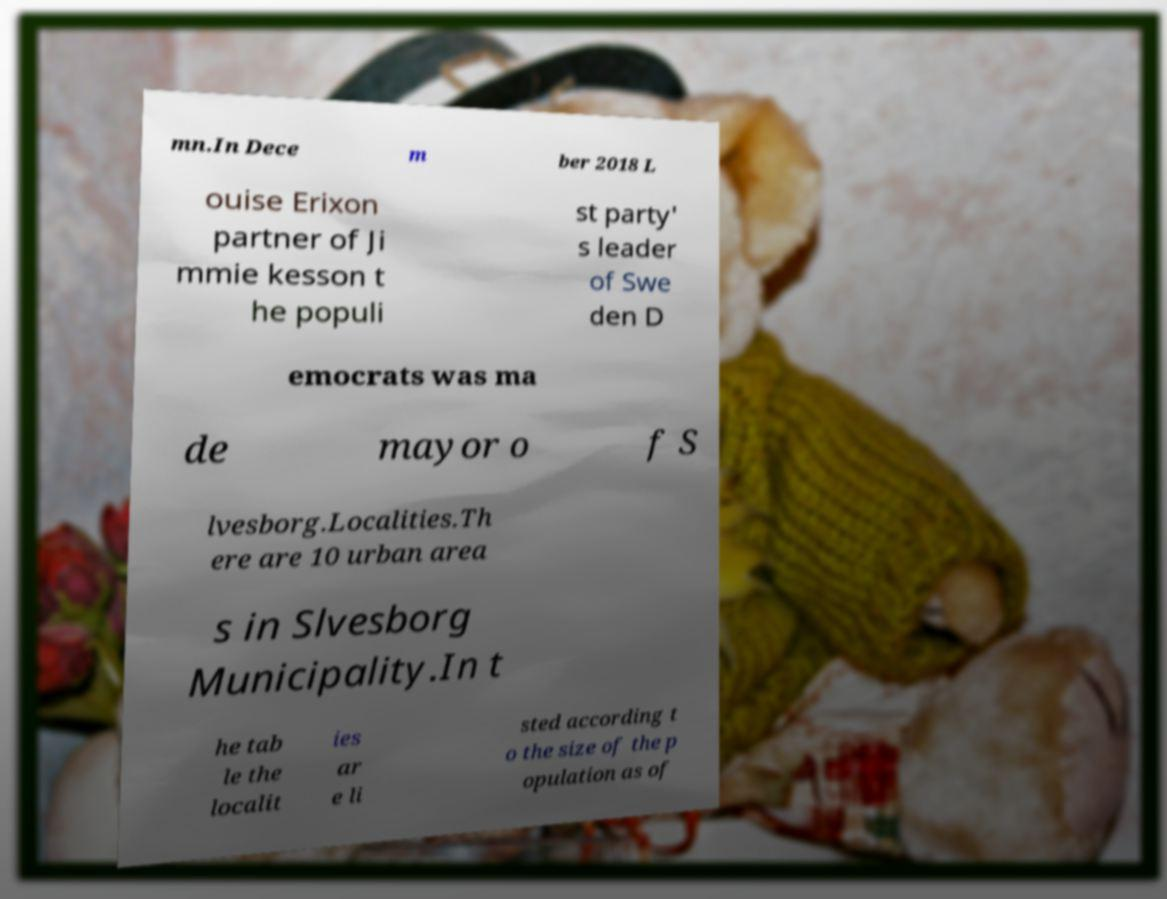What messages or text are displayed in this image? I need them in a readable, typed format. mn.In Dece m ber 2018 L ouise Erixon partner of Ji mmie kesson t he populi st party' s leader of Swe den D emocrats was ma de mayor o f S lvesborg.Localities.Th ere are 10 urban area s in Slvesborg Municipality.In t he tab le the localit ies ar e li sted according t o the size of the p opulation as of 